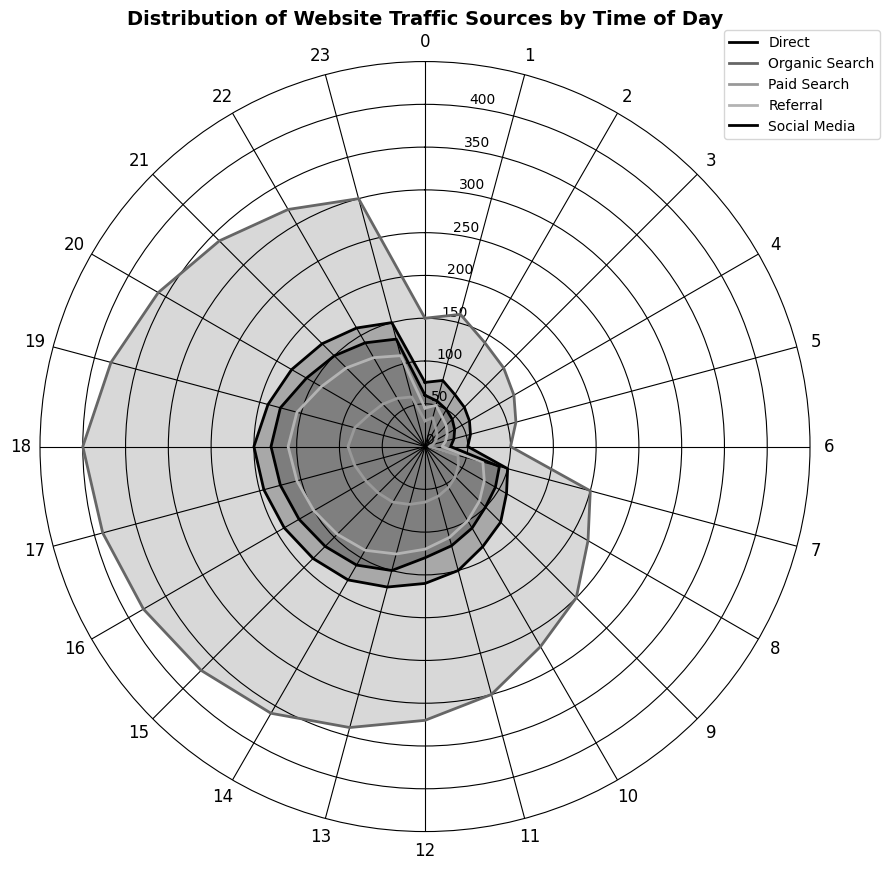How is the traffic from organic search spread out across the day? To find how organic search traffic is distributed through the day, refer to the cyclic pattern plotted around the polar chart. For each time segment, locate the radial distance of the organic search line (specific color) from the center. Traffic starts at 150 at midnight, gradually increasing to peak at 400 at around 6 PM, then dipping slightly toward the end of the day.
Answer: Peaks around 6 PM At what time of day does social media generate the highest traffic? To determine the time of day when social media generates the highest traffic, look for the time segment where the radial distance of the social media line (specific color) from the center is the greatest. Social media traffic hits its peak at 18:00 (6 PM) with a value of 180.
Answer: 18:00 Compare the total traffic from direct sources at 9 AM and 9 PM. Which time has more traffic? For this, identify the radial positions for direct traffic at both 9 AM and 9 PM. At 9 AM, the distance from center for direct sources indicates 125. At 9 PM, it shows 170.
Answer: 9 PM What is the combined traffic from paid search and referral sources at 2 PM? To calculate the combined traffic, locate the paid search and referral values for 2 PM from the chart. Adding the values, paid search (75) and referral (140) gives the total combined traffic. So, 75 + 140 = 215.
Answer: 215 When is the lowest traffic from paid search observed? Identify the radial distance of the paid search line that is closest to the center across all time segments. The minimum distance from the center for paid search traffic appears at 6 AM, which is 5.
Answer: 6 AM How does the traffic from referral sources at 3 PM compare with that at 8 PM? To compare referral traffic, observe the radial positions at both 3 PM and 8 PM. The value for referral traffic at 3 PM is 145, whereas it is 140 at 8 PM. Since 145 is greater than 140, 3 PM has slightly higher traffic.
Answer: Higher at 3 PM What's the average traffic during the day (midnight to midnight) from organic search? To find the average organic search traffic, sum up the traffic values at all times (midnight to midnight) and divide by the number of time points (24). The sum is (150 + 160 + 140 + ... + 300). Calculating, (150+160+140+130+120+110+100+200+220+250+270+300+320+340+360+370+380+390+400+380+360+340+320+300) = 6425 / 24 = 267.71.
Answer: 267.71 Does social media ever surpass organic search in traffic at any time of the day? For this, visually inspect each time segment to see if the radial distance of social media exceeds that of organic search. Organic search generally outpaces social media traffic throughout the day.
Answer: No Which period sees the steepest decline in direct traffic? Look for the largest decrease in the radial distance of direct traffic between consecutive time segments. A noticeable steep decline happens between 18:00 (200) and 06:00 (50). Calculating the difference, 200 - 50 = 150.
Answer: Between 18:00 and 06:00 At what time does referral traffic reach half of the maximum direct traffic, and what is the value? The maximum direct traffic is 200, thus half the maximum is 100. Examine each time segment to find the referral traffic equal to 100. At 10 AM, referral traffic meets this condition.
Answer: 10 AM, 100 